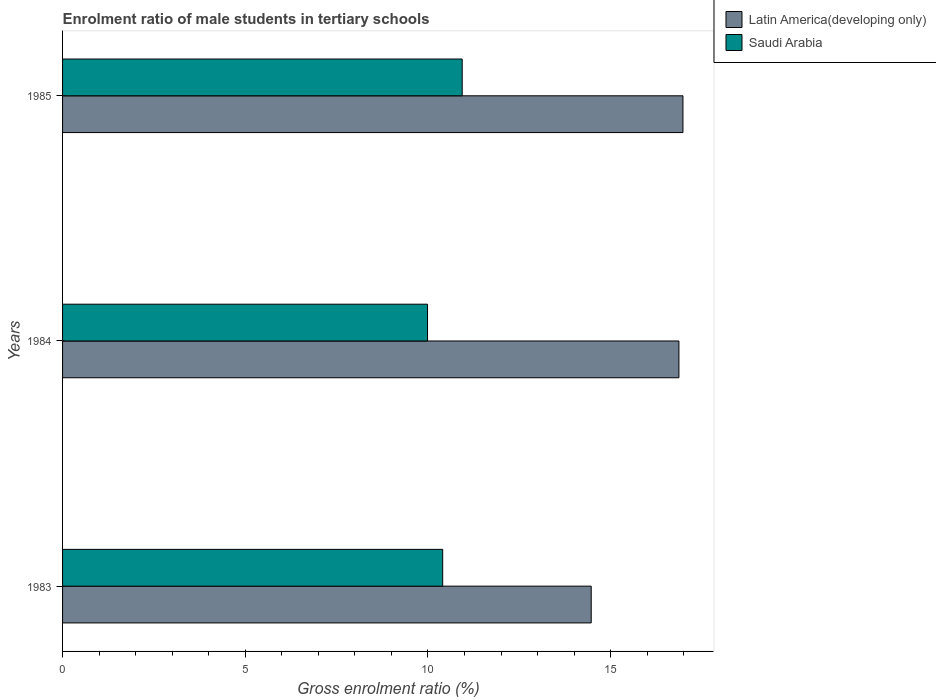How many different coloured bars are there?
Provide a short and direct response. 2. Are the number of bars on each tick of the Y-axis equal?
Ensure brevity in your answer.  Yes. How many bars are there on the 1st tick from the top?
Make the answer very short. 2. How many bars are there on the 1st tick from the bottom?
Provide a short and direct response. 2. What is the label of the 3rd group of bars from the top?
Your response must be concise. 1983. What is the enrolment ratio of male students in tertiary schools in Saudi Arabia in 1983?
Provide a short and direct response. 10.4. Across all years, what is the maximum enrolment ratio of male students in tertiary schools in Latin America(developing only)?
Your answer should be compact. 16.98. Across all years, what is the minimum enrolment ratio of male students in tertiary schools in Latin America(developing only)?
Ensure brevity in your answer.  14.47. In which year was the enrolment ratio of male students in tertiary schools in Saudi Arabia maximum?
Provide a short and direct response. 1985. What is the total enrolment ratio of male students in tertiary schools in Latin America(developing only) in the graph?
Your response must be concise. 48.32. What is the difference between the enrolment ratio of male students in tertiary schools in Saudi Arabia in 1983 and that in 1985?
Your response must be concise. -0.53. What is the difference between the enrolment ratio of male students in tertiary schools in Latin America(developing only) in 1983 and the enrolment ratio of male students in tertiary schools in Saudi Arabia in 1984?
Give a very brief answer. 4.48. What is the average enrolment ratio of male students in tertiary schools in Saudi Arabia per year?
Offer a terse response. 10.44. In the year 1984, what is the difference between the enrolment ratio of male students in tertiary schools in Saudi Arabia and enrolment ratio of male students in tertiary schools in Latin America(developing only)?
Your response must be concise. -6.88. What is the ratio of the enrolment ratio of male students in tertiary schools in Latin America(developing only) in 1983 to that in 1985?
Provide a succinct answer. 0.85. Is the enrolment ratio of male students in tertiary schools in Latin America(developing only) in 1983 less than that in 1984?
Your response must be concise. Yes. What is the difference between the highest and the second highest enrolment ratio of male students in tertiary schools in Latin America(developing only)?
Keep it short and to the point. 0.11. What is the difference between the highest and the lowest enrolment ratio of male students in tertiary schools in Saudi Arabia?
Your answer should be compact. 0.95. Is the sum of the enrolment ratio of male students in tertiary schools in Latin America(developing only) in 1983 and 1984 greater than the maximum enrolment ratio of male students in tertiary schools in Saudi Arabia across all years?
Offer a very short reply. Yes. What does the 1st bar from the top in 1983 represents?
Offer a very short reply. Saudi Arabia. What does the 2nd bar from the bottom in 1984 represents?
Your answer should be compact. Saudi Arabia. How many bars are there?
Provide a short and direct response. 6. Are all the bars in the graph horizontal?
Provide a succinct answer. Yes. How many years are there in the graph?
Keep it short and to the point. 3. Does the graph contain any zero values?
Your answer should be compact. No. Where does the legend appear in the graph?
Give a very brief answer. Top right. What is the title of the graph?
Keep it short and to the point. Enrolment ratio of male students in tertiary schools. What is the label or title of the X-axis?
Give a very brief answer. Gross enrolment ratio (%). What is the Gross enrolment ratio (%) in Latin America(developing only) in 1983?
Provide a short and direct response. 14.47. What is the Gross enrolment ratio (%) of Saudi Arabia in 1983?
Offer a terse response. 10.4. What is the Gross enrolment ratio (%) in Latin America(developing only) in 1984?
Your response must be concise. 16.87. What is the Gross enrolment ratio (%) of Saudi Arabia in 1984?
Offer a very short reply. 9.99. What is the Gross enrolment ratio (%) of Latin America(developing only) in 1985?
Your answer should be compact. 16.98. What is the Gross enrolment ratio (%) in Saudi Arabia in 1985?
Make the answer very short. 10.94. Across all years, what is the maximum Gross enrolment ratio (%) of Latin America(developing only)?
Provide a short and direct response. 16.98. Across all years, what is the maximum Gross enrolment ratio (%) of Saudi Arabia?
Your answer should be compact. 10.94. Across all years, what is the minimum Gross enrolment ratio (%) in Latin America(developing only)?
Make the answer very short. 14.47. Across all years, what is the minimum Gross enrolment ratio (%) in Saudi Arabia?
Keep it short and to the point. 9.99. What is the total Gross enrolment ratio (%) in Latin America(developing only) in the graph?
Your response must be concise. 48.32. What is the total Gross enrolment ratio (%) in Saudi Arabia in the graph?
Give a very brief answer. 31.33. What is the difference between the Gross enrolment ratio (%) of Latin America(developing only) in 1983 and that in 1984?
Ensure brevity in your answer.  -2.4. What is the difference between the Gross enrolment ratio (%) of Saudi Arabia in 1983 and that in 1984?
Provide a short and direct response. 0.41. What is the difference between the Gross enrolment ratio (%) of Latin America(developing only) in 1983 and that in 1985?
Provide a short and direct response. -2.51. What is the difference between the Gross enrolment ratio (%) in Saudi Arabia in 1983 and that in 1985?
Offer a very short reply. -0.53. What is the difference between the Gross enrolment ratio (%) of Latin America(developing only) in 1984 and that in 1985?
Offer a very short reply. -0.11. What is the difference between the Gross enrolment ratio (%) in Saudi Arabia in 1984 and that in 1985?
Your answer should be very brief. -0.95. What is the difference between the Gross enrolment ratio (%) in Latin America(developing only) in 1983 and the Gross enrolment ratio (%) in Saudi Arabia in 1984?
Your answer should be very brief. 4.48. What is the difference between the Gross enrolment ratio (%) in Latin America(developing only) in 1983 and the Gross enrolment ratio (%) in Saudi Arabia in 1985?
Give a very brief answer. 3.53. What is the difference between the Gross enrolment ratio (%) of Latin America(developing only) in 1984 and the Gross enrolment ratio (%) of Saudi Arabia in 1985?
Ensure brevity in your answer.  5.93. What is the average Gross enrolment ratio (%) in Latin America(developing only) per year?
Your answer should be compact. 16.11. What is the average Gross enrolment ratio (%) of Saudi Arabia per year?
Your answer should be very brief. 10.44. In the year 1983, what is the difference between the Gross enrolment ratio (%) in Latin America(developing only) and Gross enrolment ratio (%) in Saudi Arabia?
Ensure brevity in your answer.  4.06. In the year 1984, what is the difference between the Gross enrolment ratio (%) of Latin America(developing only) and Gross enrolment ratio (%) of Saudi Arabia?
Ensure brevity in your answer.  6.88. In the year 1985, what is the difference between the Gross enrolment ratio (%) in Latin America(developing only) and Gross enrolment ratio (%) in Saudi Arabia?
Your answer should be very brief. 6.04. What is the ratio of the Gross enrolment ratio (%) of Latin America(developing only) in 1983 to that in 1984?
Provide a succinct answer. 0.86. What is the ratio of the Gross enrolment ratio (%) of Saudi Arabia in 1983 to that in 1984?
Give a very brief answer. 1.04. What is the ratio of the Gross enrolment ratio (%) of Latin America(developing only) in 1983 to that in 1985?
Your response must be concise. 0.85. What is the ratio of the Gross enrolment ratio (%) of Saudi Arabia in 1983 to that in 1985?
Ensure brevity in your answer.  0.95. What is the ratio of the Gross enrolment ratio (%) in Latin America(developing only) in 1984 to that in 1985?
Offer a very short reply. 0.99. What is the ratio of the Gross enrolment ratio (%) in Saudi Arabia in 1984 to that in 1985?
Your answer should be compact. 0.91. What is the difference between the highest and the second highest Gross enrolment ratio (%) in Latin America(developing only)?
Your response must be concise. 0.11. What is the difference between the highest and the second highest Gross enrolment ratio (%) of Saudi Arabia?
Keep it short and to the point. 0.53. What is the difference between the highest and the lowest Gross enrolment ratio (%) of Latin America(developing only)?
Keep it short and to the point. 2.51. What is the difference between the highest and the lowest Gross enrolment ratio (%) of Saudi Arabia?
Make the answer very short. 0.95. 